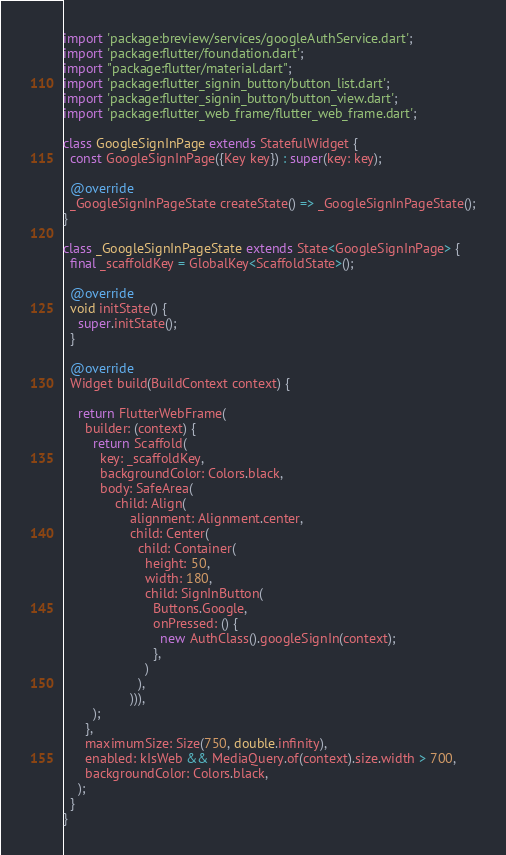Convert code to text. <code><loc_0><loc_0><loc_500><loc_500><_Dart_>
import 'package:breview/services/googleAuthService.dart';
import 'package:flutter/foundation.dart';
import "package:flutter/material.dart";
import 'package:flutter_signin_button/button_list.dart';
import 'package:flutter_signin_button/button_view.dart';
import 'package:flutter_web_frame/flutter_web_frame.dart';

class GoogleSignInPage extends StatefulWidget {
  const GoogleSignInPage({Key key}) : super(key: key);

  @override
  _GoogleSignInPageState createState() => _GoogleSignInPageState();
}

class _GoogleSignInPageState extends State<GoogleSignInPage> {
  final _scaffoldKey = GlobalKey<ScaffoldState>();

  @override
  void initState() {
    super.initState();
  }

  @override
  Widget build(BuildContext context) {

    return FlutterWebFrame(
      builder: (context) {
        return Scaffold(
          key: _scaffoldKey,
          backgroundColor: Colors.black,
          body: SafeArea(
              child: Align(
                  alignment: Alignment.center,
                  child: Center(
                    child: Container(
                      height: 50,
                      width: 180,
                      child: SignInButton(
                        Buttons.Google,
                        onPressed: () {
                          new AuthClass().googleSignIn(context);
                        },
                      )
                    ),
                  ))),
        );
      },
      maximumSize: Size(750, double.infinity),
      enabled: kIsWeb && MediaQuery.of(context).size.width > 700,
      backgroundColor: Colors.black,
    );
  }
}</code> 